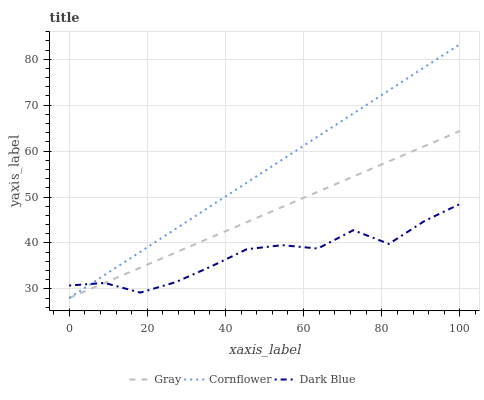Does Dark Blue have the minimum area under the curve?
Answer yes or no. Yes. Does Cornflower have the maximum area under the curve?
Answer yes or no. Yes. Does Cornflower have the minimum area under the curve?
Answer yes or no. No. Does Dark Blue have the maximum area under the curve?
Answer yes or no. No. Is Gray the smoothest?
Answer yes or no. Yes. Is Dark Blue the roughest?
Answer yes or no. Yes. Is Cornflower the smoothest?
Answer yes or no. No. Is Cornflower the roughest?
Answer yes or no. No. Does Gray have the lowest value?
Answer yes or no. Yes. Does Dark Blue have the lowest value?
Answer yes or no. No. Does Cornflower have the highest value?
Answer yes or no. Yes. Does Dark Blue have the highest value?
Answer yes or no. No. Does Cornflower intersect Gray?
Answer yes or no. Yes. Is Cornflower less than Gray?
Answer yes or no. No. Is Cornflower greater than Gray?
Answer yes or no. No. 